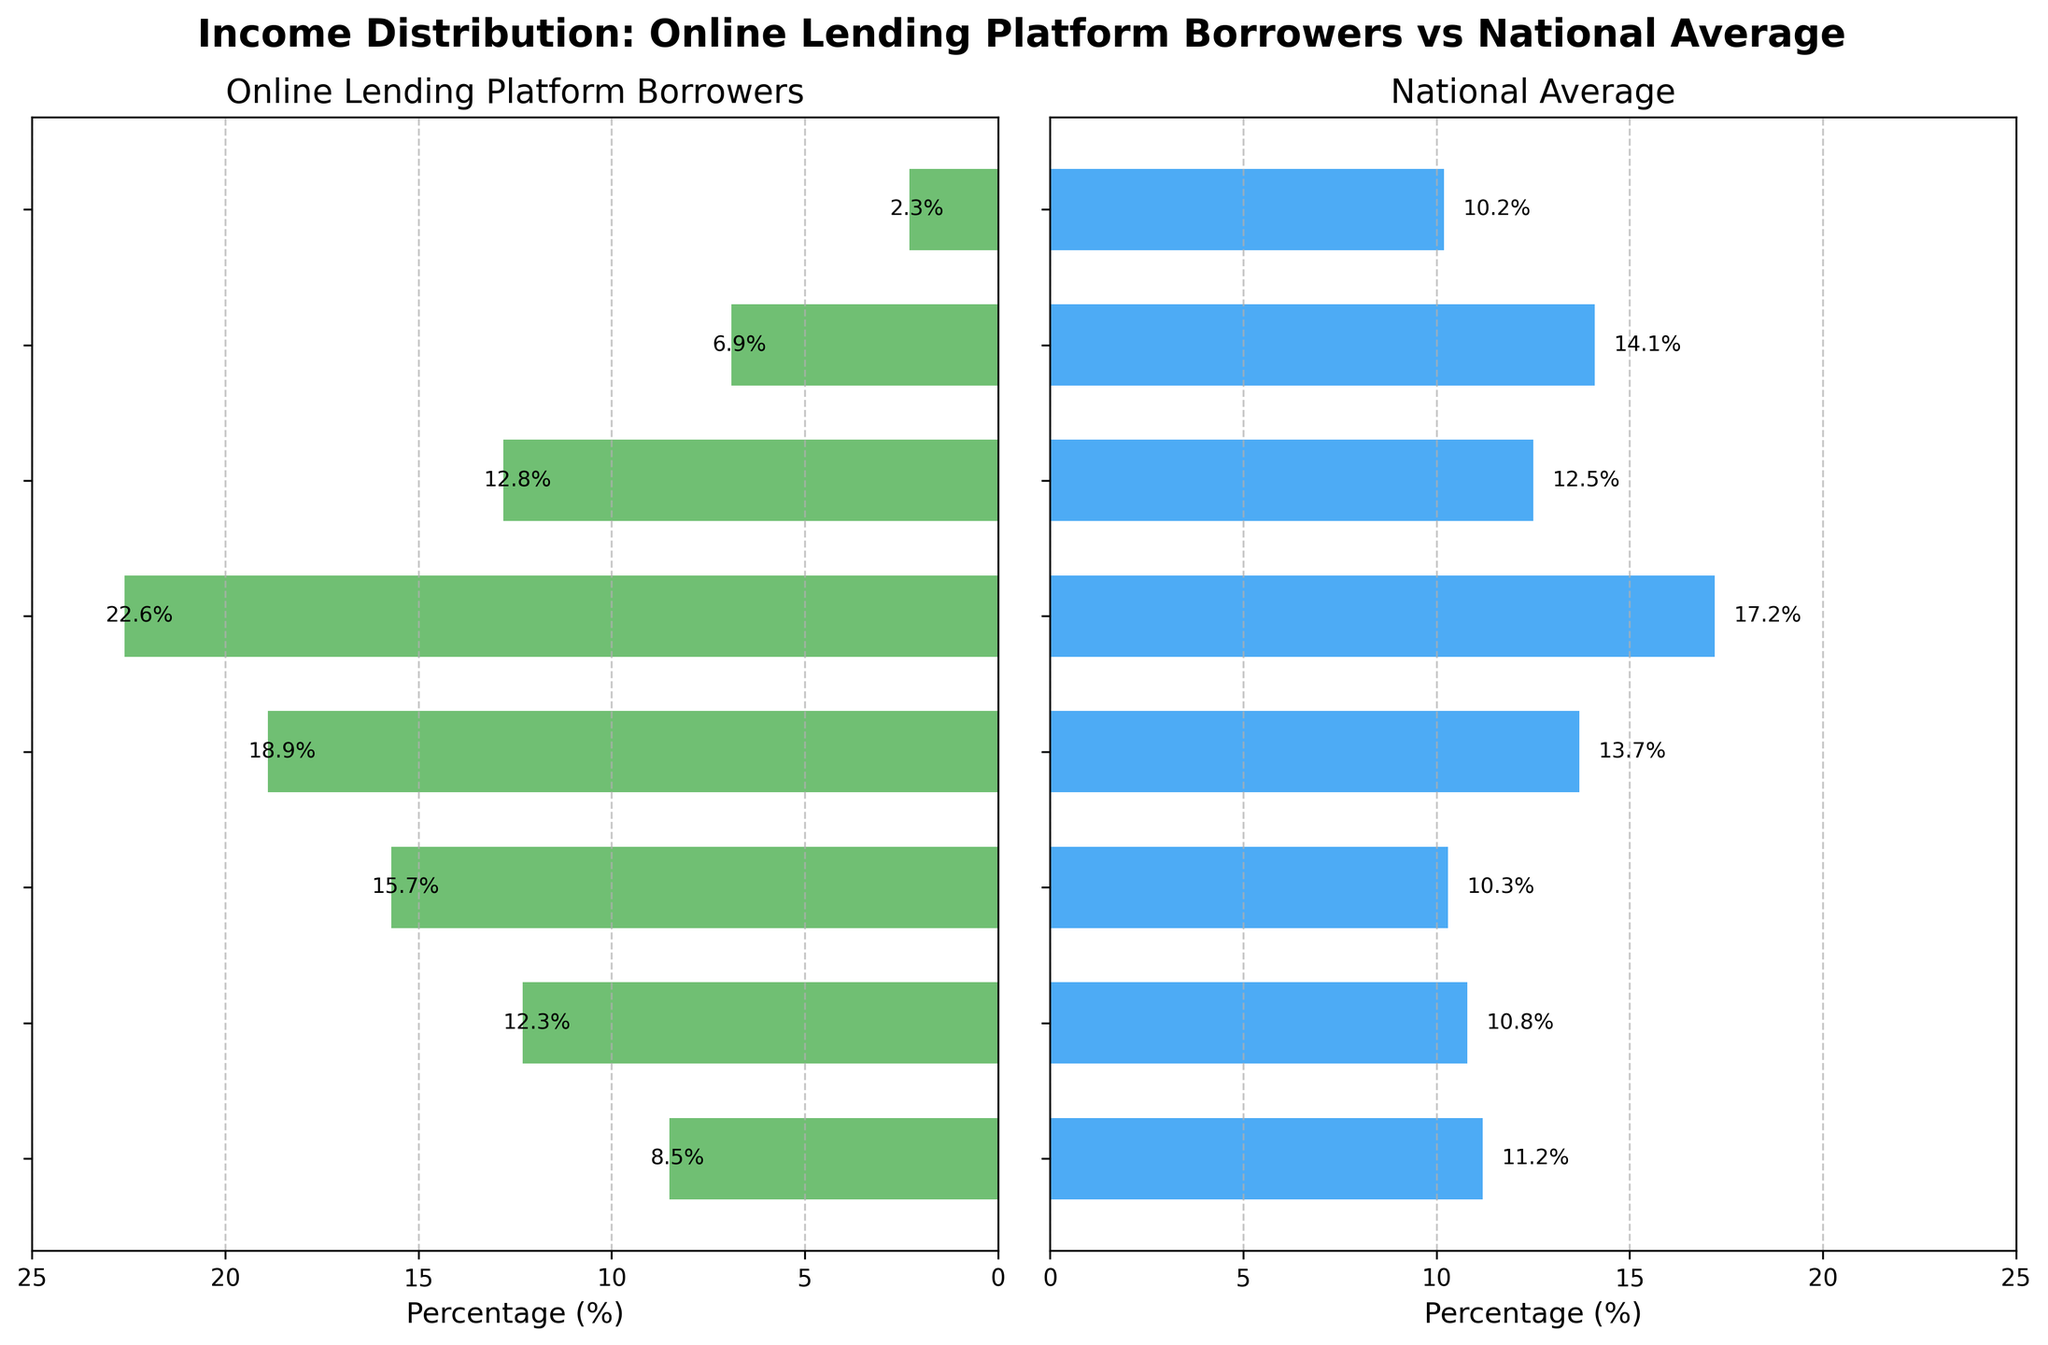What is the title of the figure? The title is typically at the top of the plot. It states the overall subject of the data being presented.
Answer: Income Distribution: Online Lending Platform Borrowers vs National Average Which income level has the highest percentage of online lending platform borrowers? Check the horizontal bar chart on the left side and identify the bar with the greatest length.
Answer: $50000-$74999 What percentage of borrowers on online lending platforms fall within the $25,000-$34,999 income level? Look at the horizontal bar chart on the left side and locate the percentage value labeled on the bar next to the $25,000-$34,999 income level.
Answer: 15.7% Which income level shows a significant difference between online lending platform borrowers and the national average? Identify bars with a noticeable length difference between the two charts. Specifically, large discrepancies typically stand out visually.
Answer: $100000-$149999 How does the percentage of online lending platform borrowers in the $15000-$24999 income level compare to the national average? Compare the bar length for the $15000-$24999 income level in both the left and right charts. Look for which bar is longer.
Answer: Higher for online lending platform borrowers Which group has fewer borrowers: those earning under $15,000 or those earning $150,000 and above? Compare the lengths of the bars corresponding to Under $15000 and $150000 and above on the left side of the chart.
Answer: $150000 and above What is the combined percentage of online borrowing platform borrowers with incomes between $50,000 and $100,000? Add the percentages of borrowers in the $50000-$74999 and $75000-$99999 income levels from the left chart.
Answer: 22.6% + 12.8% = 35.4% Is there a consistent trend in the distribution of income levels among online lending platform borrowers compared to the national average? Look for patterns in the bar lengths across various income levels. A consistent trend would show a systematic difference or similarity across income levels.
Answer: No consistent trend; differences vary by income level Which income level has close to equal representation between online lending platform borrowers and the national average? Compare bar lengths in both charts where the values are nearly the same.
Answer: $75000-$99999 How does the representation of higher-income borrowers (earning $100,000 and above) on online lending platforms compare to the national average? Focus on the lengths of the bars representing $100000-$149999 and $150000 and above in both charts and compare them.
Answer: Lower for online lending platform borrowers 